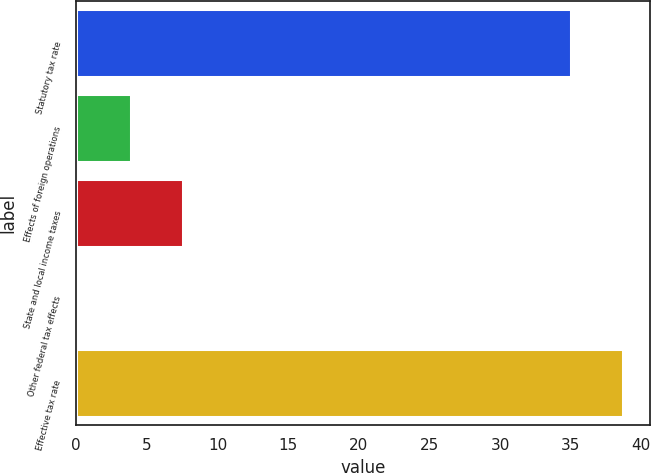Convert chart. <chart><loc_0><loc_0><loc_500><loc_500><bar_chart><fcel>Statutory tax rate<fcel>Effects of foreign operations<fcel>State and local income taxes<fcel>Other federal tax effects<fcel>Effective tax rate<nl><fcel>35<fcel>3.89<fcel>7.58<fcel>0.2<fcel>38.69<nl></chart> 